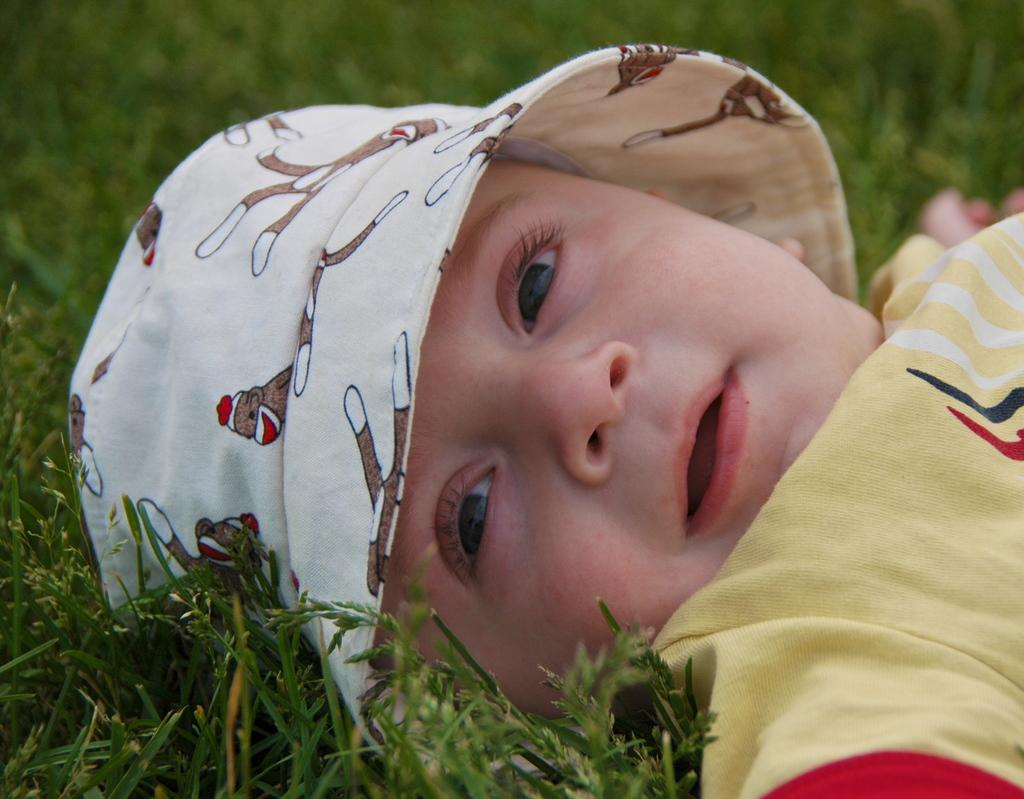What is the main subject of the picture? The main subject of the picture is a small baby. Where is the baby located in the image? The baby is lying on a grass surface. What is the baby wearing on their upper body? The baby is wearing a yellow T-shirt. What type of headwear is the baby wearing? The baby is wearing a white hat with designs on it. What type of bridge can be seen in the background of the image? There is no bridge visible in the image; it features a small baby lying on a grass surface. 